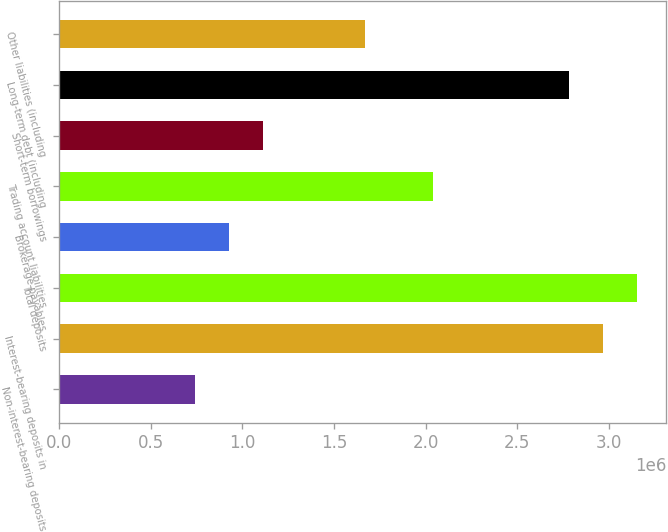Convert chart to OTSL. <chart><loc_0><loc_0><loc_500><loc_500><bar_chart><fcel>Non-interest-bearing deposits<fcel>Interest-bearing deposits in<fcel>Total deposits<fcel>Brokerage payables<fcel>Trading account liabilities<fcel>Short-term borrowings<fcel>Long-term debt (including<fcel>Other liabilities (including<nl><fcel>742846<fcel>2.97045e+06<fcel>3.15608e+06<fcel>928479<fcel>2.04228e+06<fcel>1.11411e+06<fcel>2.78481e+06<fcel>1.67101e+06<nl></chart> 